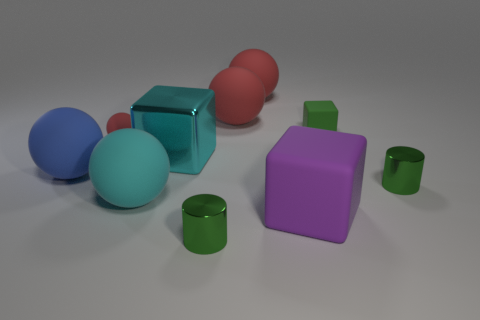There is another big thing that is the same color as the large metallic object; what is its material?
Make the answer very short. Rubber. What number of things are blocks behind the big cyan matte object or matte balls behind the big cyan metallic block?
Provide a succinct answer. 5. What number of tiny cylinders are on the left side of the small green cylinder in front of the large purple thing?
Provide a short and direct response. 0. There is a tiny block that is made of the same material as the tiny ball; what color is it?
Your answer should be very brief. Green. Are there any metallic cylinders of the same size as the blue object?
Provide a short and direct response. No. The cyan matte thing that is the same size as the blue sphere is what shape?
Provide a short and direct response. Sphere. Are there any purple things that have the same shape as the big cyan shiny thing?
Keep it short and to the point. Yes. Do the purple cube and the cube left of the large rubber cube have the same material?
Your answer should be compact. No. Is there a small block that has the same color as the small matte ball?
Keep it short and to the point. No. What number of other things are there of the same material as the small block
Your answer should be compact. 6. 